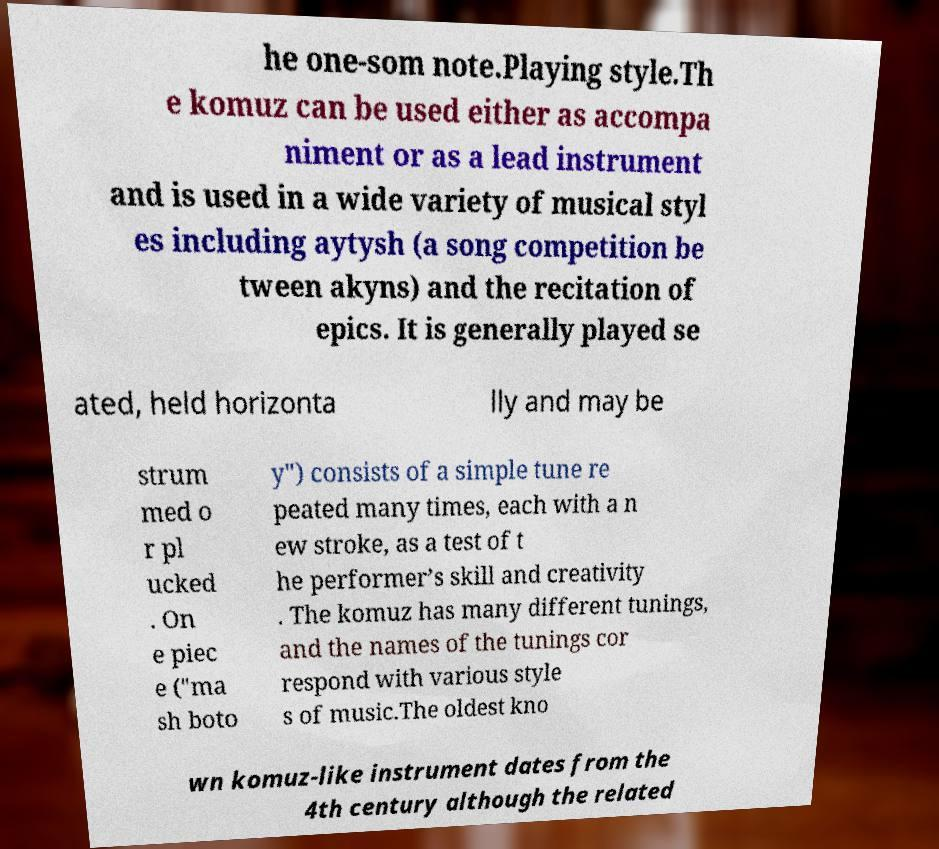I need the written content from this picture converted into text. Can you do that? he one-som note.Playing style.Th e komuz can be used either as accompa niment or as a lead instrument and is used in a wide variety of musical styl es including aytysh (a song competition be tween akyns) and the recitation of epics. It is generally played se ated, held horizonta lly and may be strum med o r pl ucked . On e piec e ("ma sh boto y") consists of a simple tune re peated many times, each with a n ew stroke, as a test of t he performer’s skill and creativity . The komuz has many different tunings, and the names of the tunings cor respond with various style s of music.The oldest kno wn komuz-like instrument dates from the 4th century although the related 